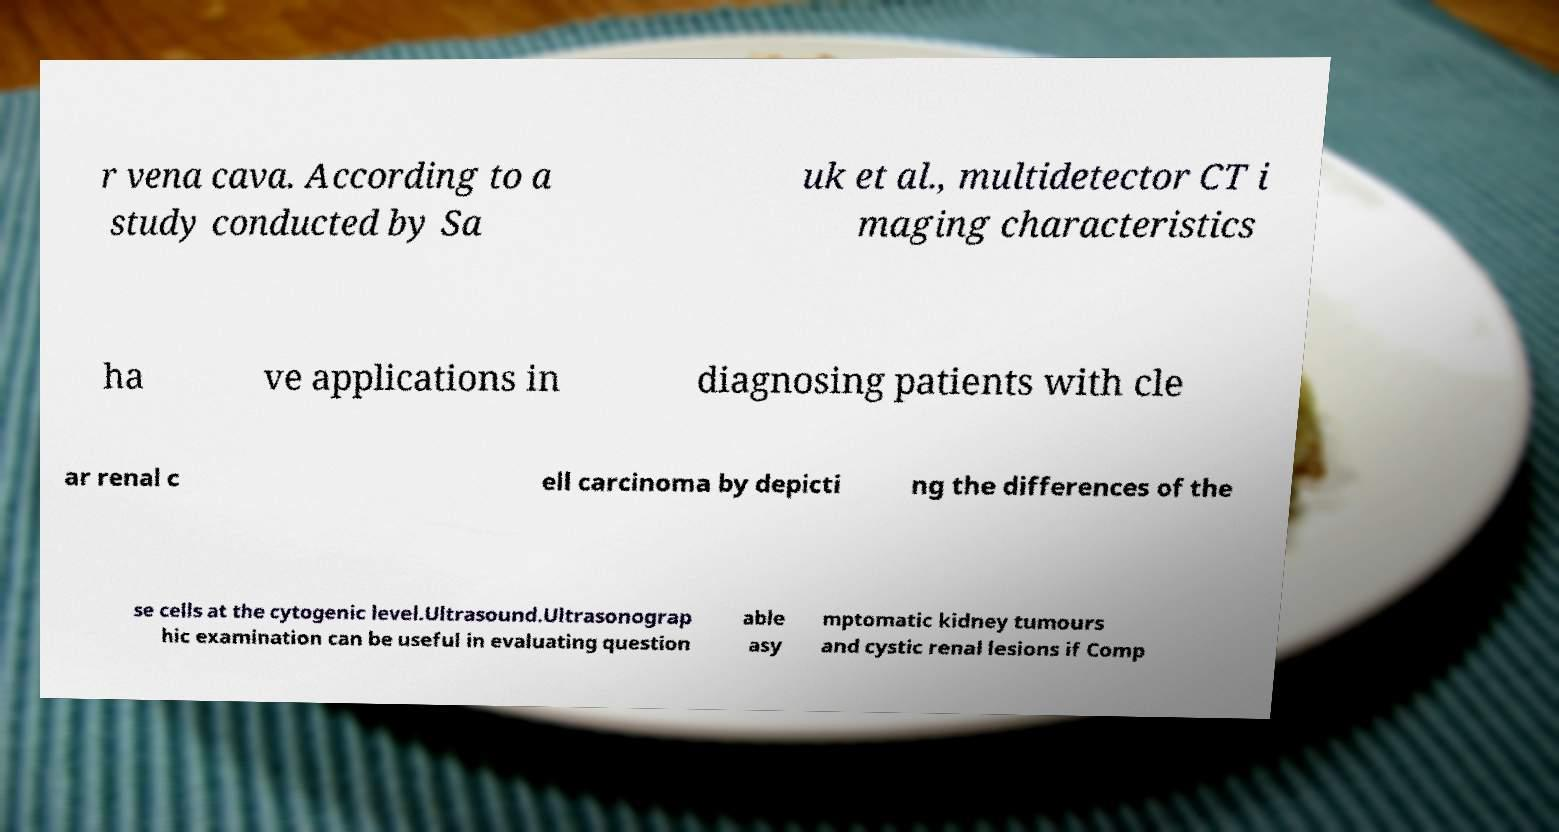I need the written content from this picture converted into text. Can you do that? r vena cava. According to a study conducted by Sa uk et al., multidetector CT i maging characteristics ha ve applications in diagnosing patients with cle ar renal c ell carcinoma by depicti ng the differences of the se cells at the cytogenic level.Ultrasound.Ultrasonograp hic examination can be useful in evaluating question able asy mptomatic kidney tumours and cystic renal lesions if Comp 